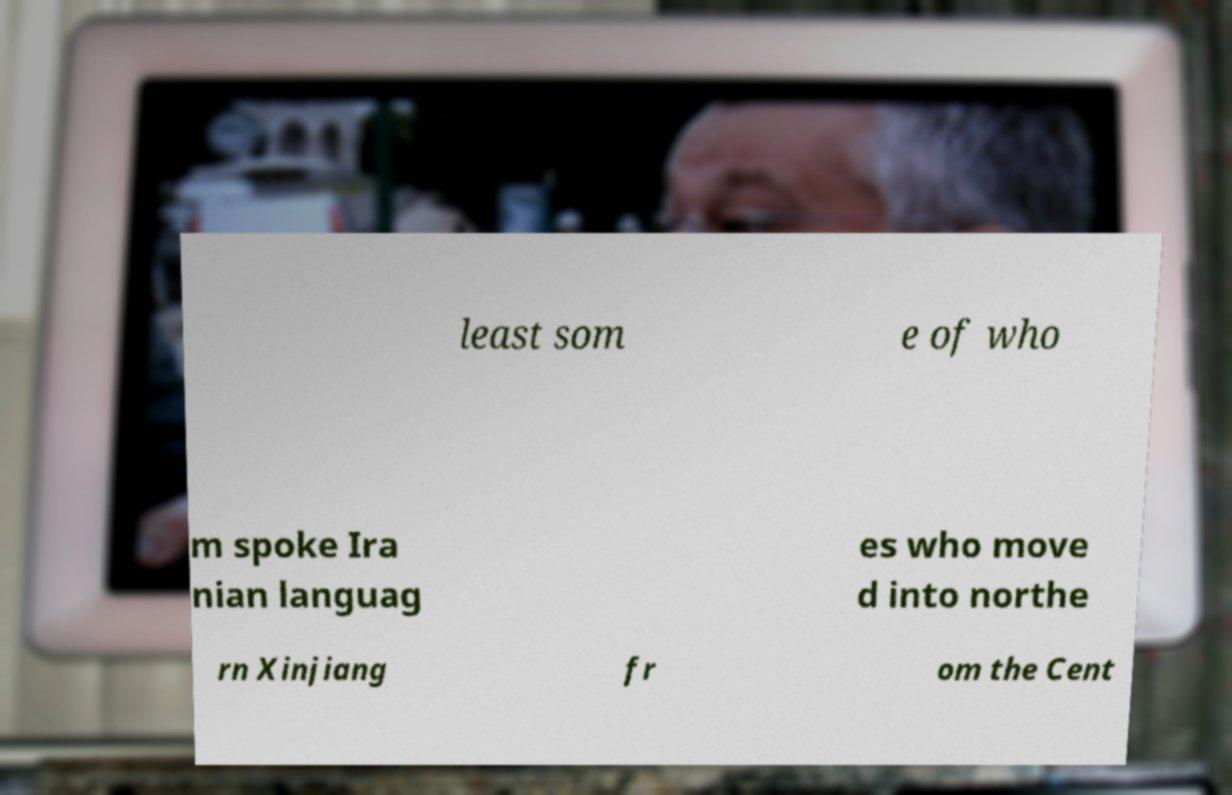What messages or text are displayed in this image? I need them in a readable, typed format. least som e of who m spoke Ira nian languag es who move d into northe rn Xinjiang fr om the Cent 